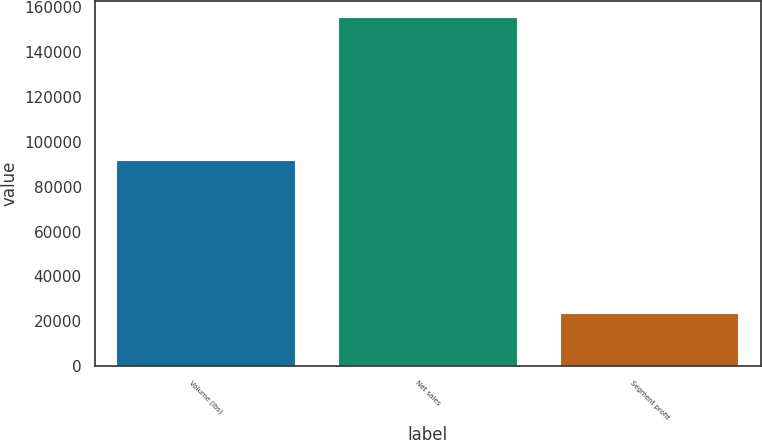<chart> <loc_0><loc_0><loc_500><loc_500><bar_chart><fcel>Volume (lbs)<fcel>Net sales<fcel>Segment profit<nl><fcel>91414<fcel>155130<fcel>23113<nl></chart> 